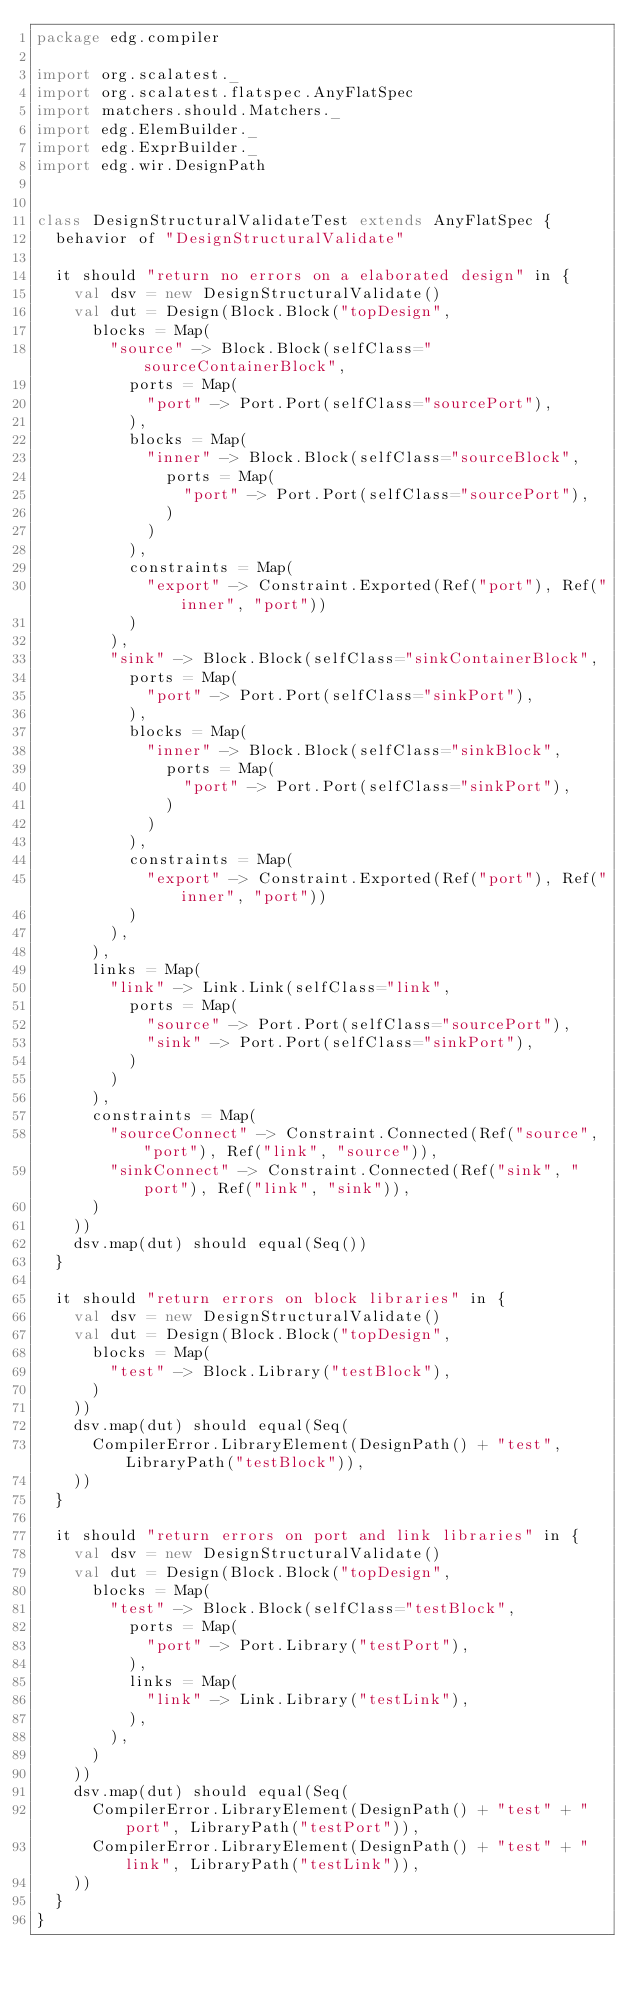Convert code to text. <code><loc_0><loc_0><loc_500><loc_500><_Scala_>package edg.compiler

import org.scalatest._
import org.scalatest.flatspec.AnyFlatSpec
import matchers.should.Matchers._
import edg.ElemBuilder._
import edg.ExprBuilder._
import edg.wir.DesignPath


class DesignStructuralValidateTest extends AnyFlatSpec {
  behavior of "DesignStructuralValidate"

  it should "return no errors on a elaborated design" in {
    val dsv = new DesignStructuralValidate()
    val dut = Design(Block.Block("topDesign",
      blocks = Map(
        "source" -> Block.Block(selfClass="sourceContainerBlock",
          ports = Map(
            "port" -> Port.Port(selfClass="sourcePort"),
          ),
          blocks = Map(
            "inner" -> Block.Block(selfClass="sourceBlock",
              ports = Map(
                "port" -> Port.Port(selfClass="sourcePort"),
              )
            )
          ),
          constraints = Map(
            "export" -> Constraint.Exported(Ref("port"), Ref("inner", "port"))
          )
        ),
        "sink" -> Block.Block(selfClass="sinkContainerBlock",
          ports = Map(
            "port" -> Port.Port(selfClass="sinkPort"),
          ),
          blocks = Map(
            "inner" -> Block.Block(selfClass="sinkBlock",
              ports = Map(
                "port" -> Port.Port(selfClass="sinkPort"),
              )
            )
          ),
          constraints = Map(
            "export" -> Constraint.Exported(Ref("port"), Ref("inner", "port"))
          )
        ),
      ),
      links = Map(
        "link" -> Link.Link(selfClass="link",
          ports = Map(
            "source" -> Port.Port(selfClass="sourcePort"),
            "sink" -> Port.Port(selfClass="sinkPort"),
          )
        )
      ),
      constraints = Map(
        "sourceConnect" -> Constraint.Connected(Ref("source", "port"), Ref("link", "source")),
        "sinkConnect" -> Constraint.Connected(Ref("sink", "port"), Ref("link", "sink")),
      )
    ))
    dsv.map(dut) should equal(Seq())
  }

  it should "return errors on block libraries" in {
    val dsv = new DesignStructuralValidate()
    val dut = Design(Block.Block("topDesign",
      blocks = Map(
        "test" -> Block.Library("testBlock"),
      )
    ))
    dsv.map(dut) should equal(Seq(
      CompilerError.LibraryElement(DesignPath() + "test", LibraryPath("testBlock")),
    ))
  }

  it should "return errors on port and link libraries" in {
    val dsv = new DesignStructuralValidate()
    val dut = Design(Block.Block("topDesign",
      blocks = Map(
        "test" -> Block.Block(selfClass="testBlock",
          ports = Map(
            "port" -> Port.Library("testPort"),
          ),
          links = Map(
            "link" -> Link.Library("testLink"),
          ),
        ),
      )
    ))
    dsv.map(dut) should equal(Seq(
      CompilerError.LibraryElement(DesignPath() + "test" + "port", LibraryPath("testPort")),
      CompilerError.LibraryElement(DesignPath() + "test" + "link", LibraryPath("testLink")),
    ))
  }
}
</code> 